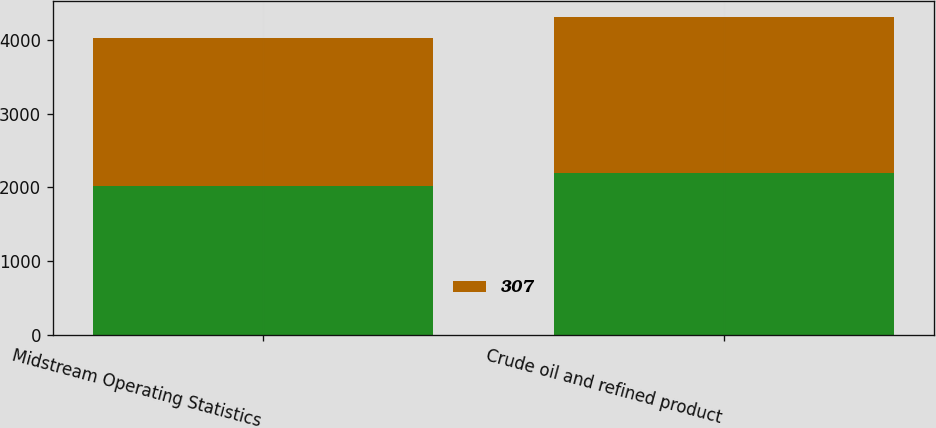Convert chart. <chart><loc_0><loc_0><loc_500><loc_500><stacked_bar_chart><ecel><fcel>Midstream Operating Statistics<fcel>Crude oil and refined product<nl><fcel>nan<fcel>2015<fcel>2191<nl><fcel>307<fcel>2014<fcel>2119<nl></chart> 